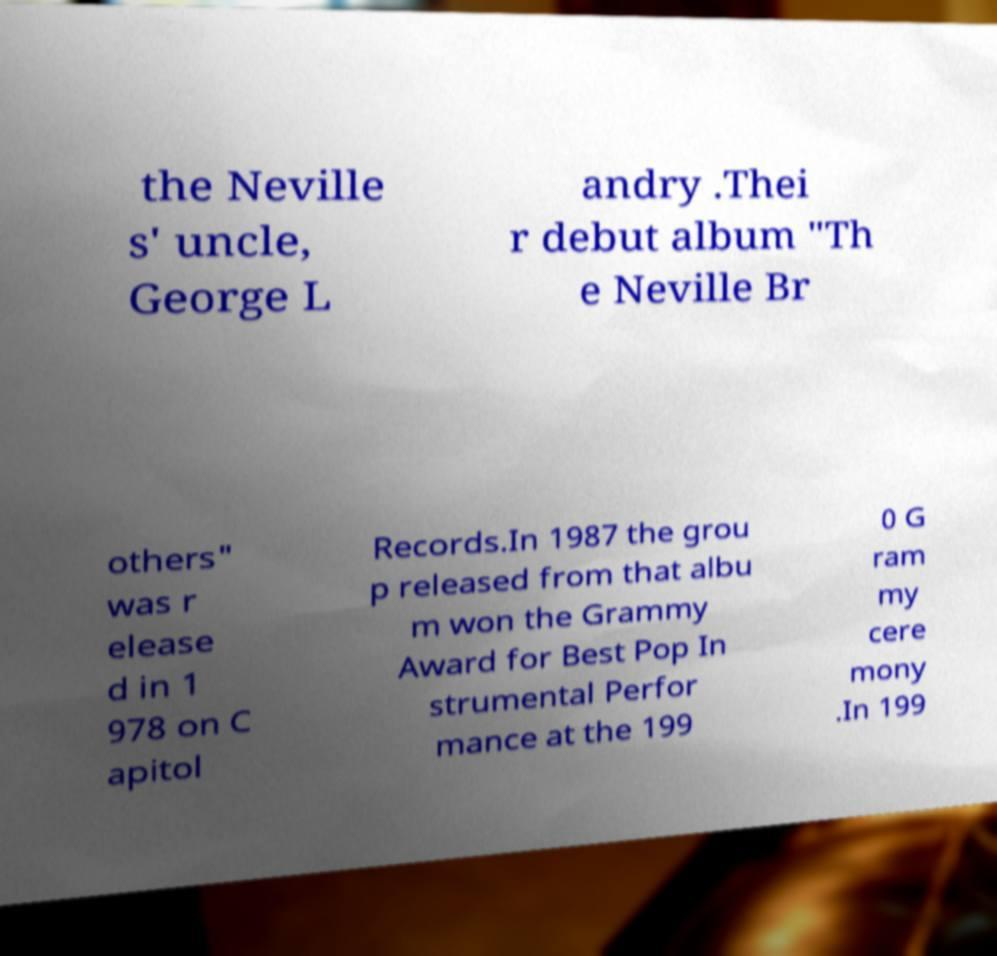Please read and relay the text visible in this image. What does it say? the Neville s' uncle, George L andry .Thei r debut album "Th e Neville Br others" was r elease d in 1 978 on C apitol Records.In 1987 the grou p released from that albu m won the Grammy Award for Best Pop In strumental Perfor mance at the 199 0 G ram my cere mony .In 199 